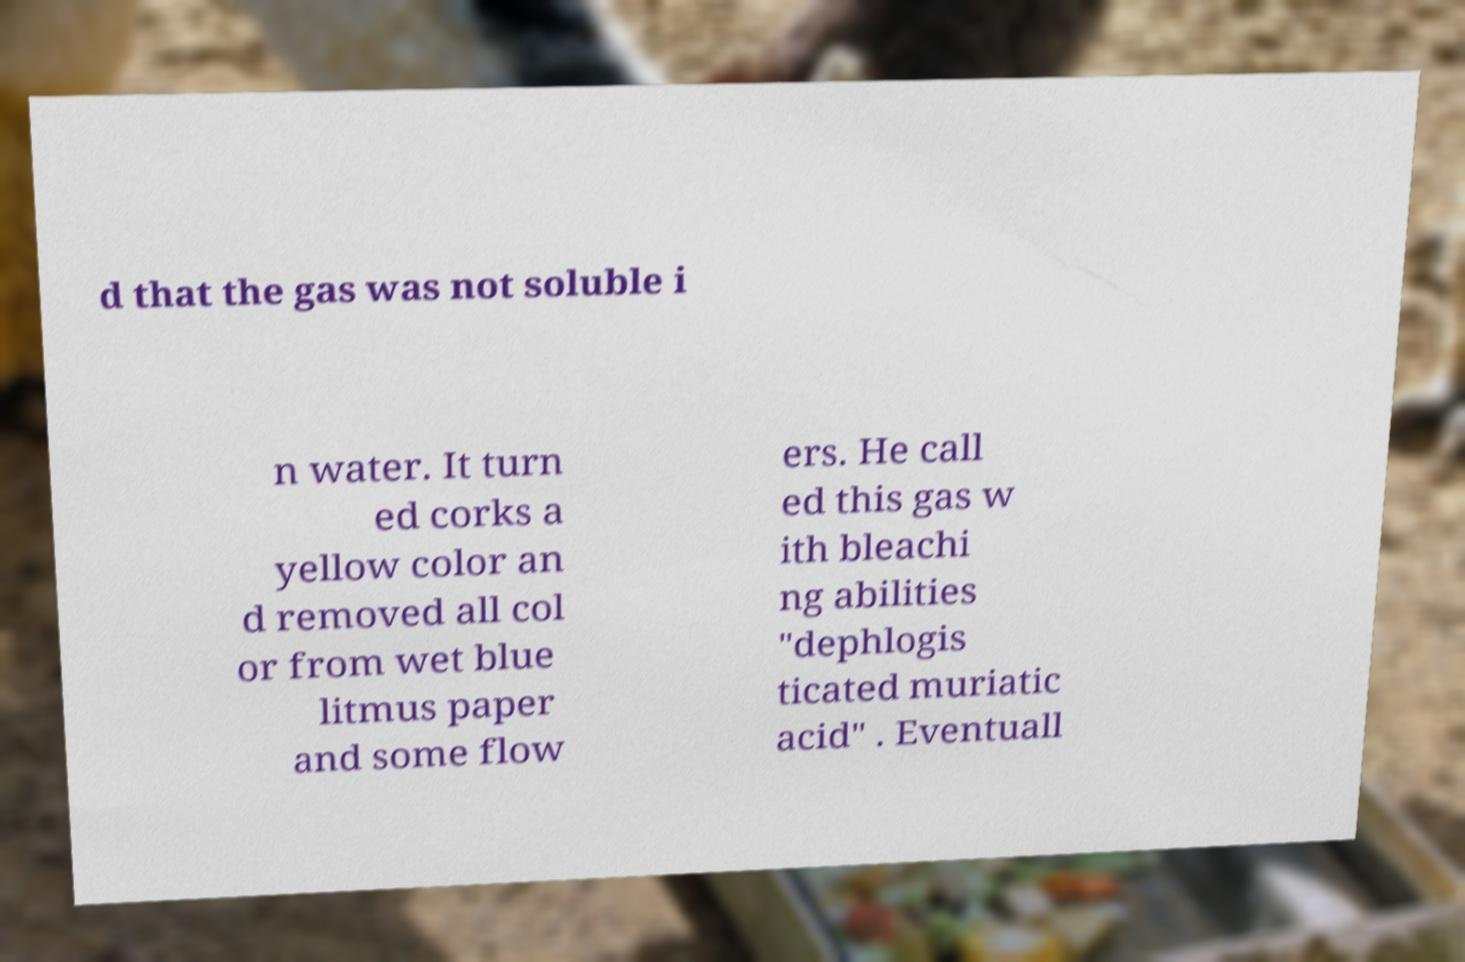What messages or text are displayed in this image? I need them in a readable, typed format. d that the gas was not soluble i n water. It turn ed corks a yellow color an d removed all col or from wet blue litmus paper and some flow ers. He call ed this gas w ith bleachi ng abilities "dephlogis ticated muriatic acid" . Eventuall 